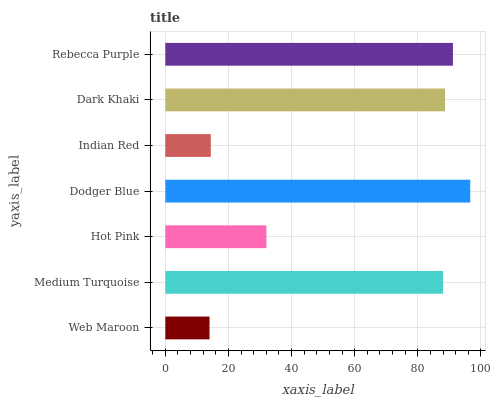Is Web Maroon the minimum?
Answer yes or no. Yes. Is Dodger Blue the maximum?
Answer yes or no. Yes. Is Medium Turquoise the minimum?
Answer yes or no. No. Is Medium Turquoise the maximum?
Answer yes or no. No. Is Medium Turquoise greater than Web Maroon?
Answer yes or no. Yes. Is Web Maroon less than Medium Turquoise?
Answer yes or no. Yes. Is Web Maroon greater than Medium Turquoise?
Answer yes or no. No. Is Medium Turquoise less than Web Maroon?
Answer yes or no. No. Is Medium Turquoise the high median?
Answer yes or no. Yes. Is Medium Turquoise the low median?
Answer yes or no. Yes. Is Dark Khaki the high median?
Answer yes or no. No. Is Hot Pink the low median?
Answer yes or no. No. 